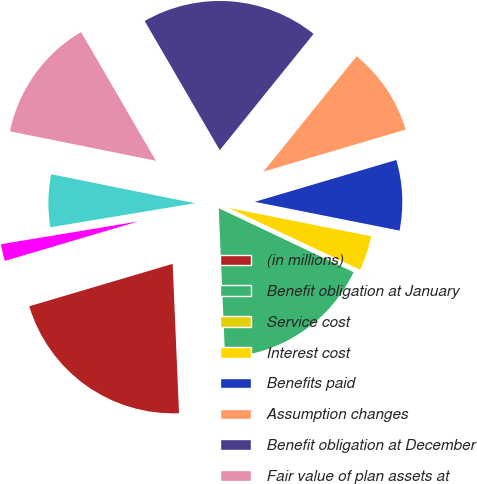Convert chart to OTSL. <chart><loc_0><loc_0><loc_500><loc_500><pie_chart><fcel>(in millions)<fcel>Benefit obligation at January<fcel>Service cost<fcel>Interest cost<fcel>Benefits paid<fcel>Assumption changes<fcel>Benefit obligation at December<fcel>Fair value of plan assets at<fcel>Actual return on plan assets<fcel>Employer contributions<nl><fcel>21.1%<fcel>17.27%<fcel>0.05%<fcel>3.88%<fcel>7.7%<fcel>9.62%<fcel>19.19%<fcel>13.45%<fcel>5.79%<fcel>1.96%<nl></chart> 